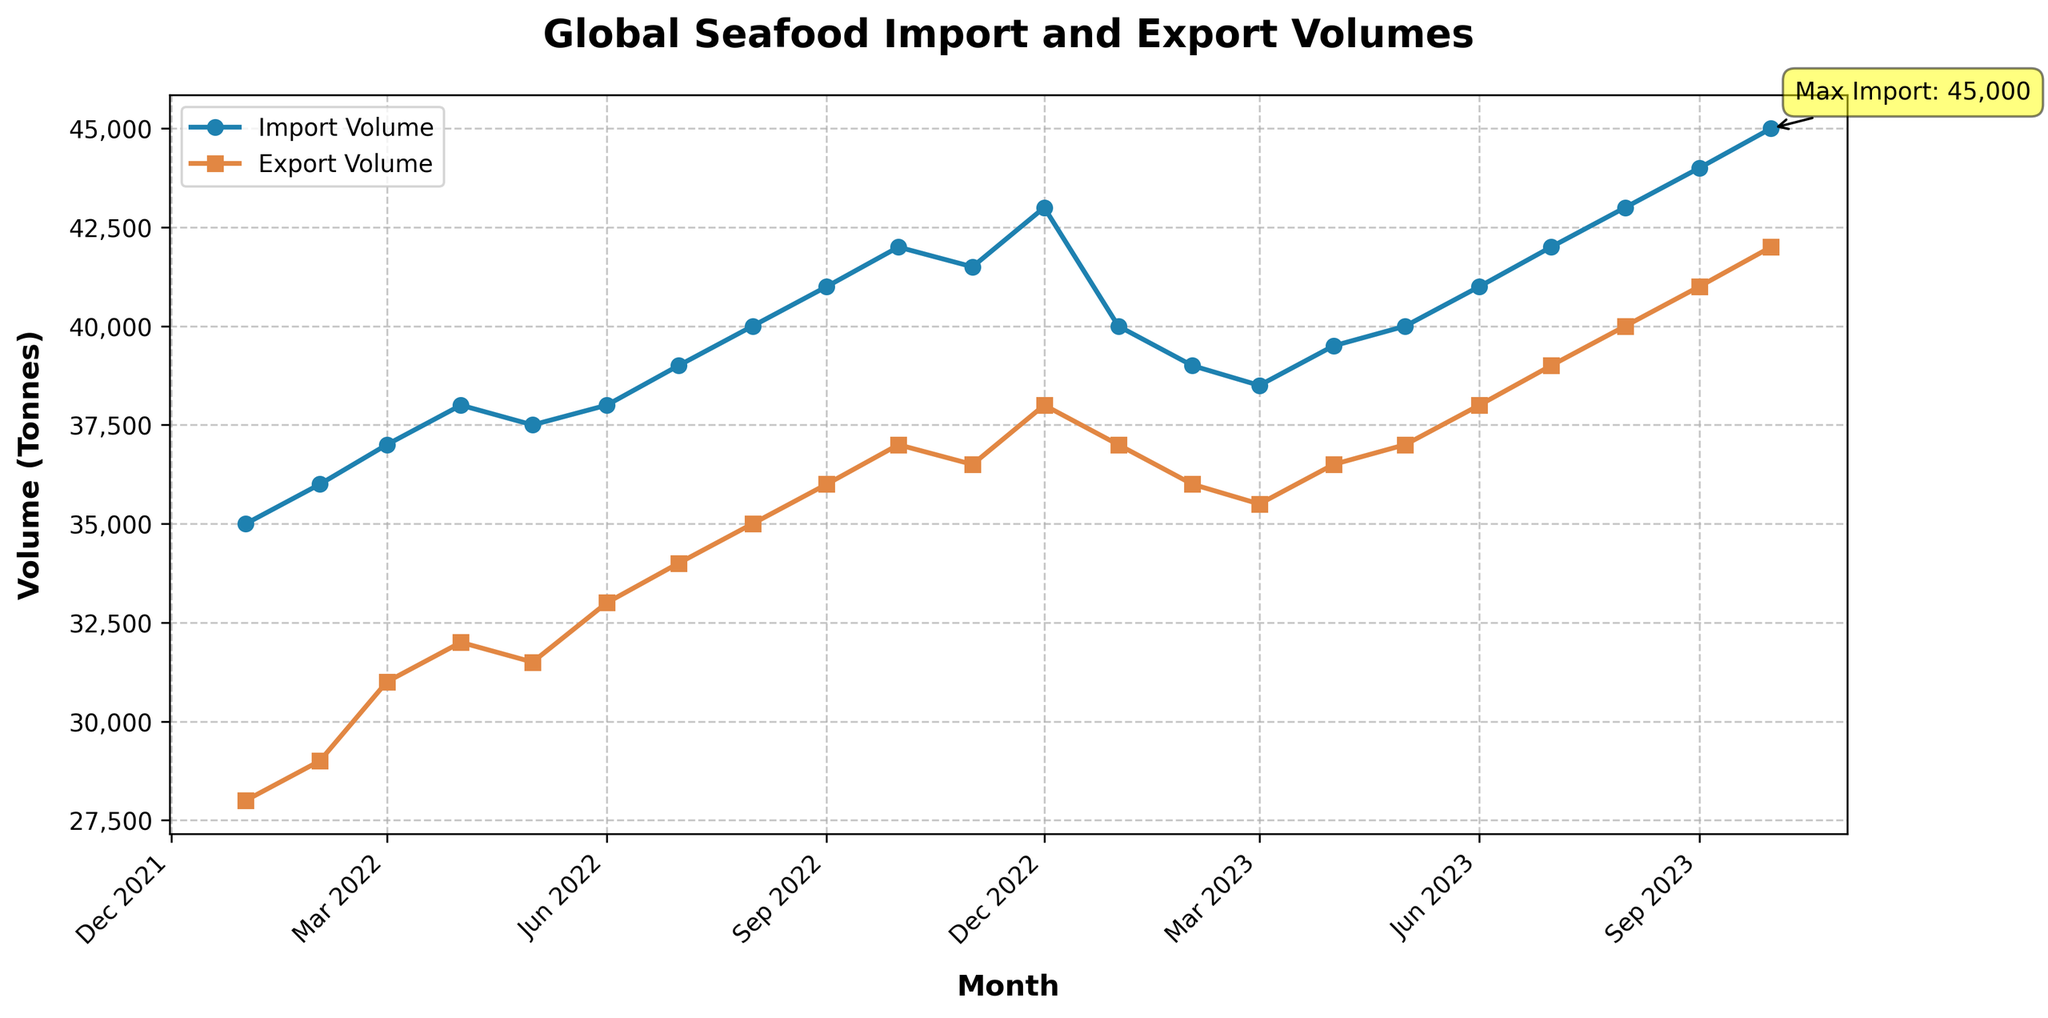What is the title of the plot? The title of the plot is displayed at the top of the figure. It provides a summary of what the chart is about.
Answer: Global Seafood Import and Export Volumes What is the maximum import volume and when did it occur? By examining the 'Import Volume' series, the highest point on the plot represents the maximum import volume. The annotation also highlights it.
Answer: 45,000 tonnes in October 2023 Which month had the lowest export volume and what was its value? By looking at the 'Export Volume' series, the lowest point on the plot represents the lowest export volume. This occurred at the beginning of the series.
Answer: January 2022 with 28,000 tonnes How does the import volume in January 2023 compare to its value in January 2022? By locating January 2022 and January 2023 on the x-axis and comparing their corresponding import values on the y-axis, we can determine the difference or increase.
Answer: Import volume decreased from 35,000 tonnes to 40,000 tonnes Over the entire period, how many months saw a decrease in export volume compared to the previous month? By checking the 'Export Volume' series, each data point can be compared to the previous month to count the months with a decrease. There are three such periods: January 2023, February 2023, and March 2023.
Answer: 3 months What is the general trend for seafood import volumes from January 2022 to October 2023? Observing the 'Import Volume' series, the line generally slopes upwards, indicating an increasing trend over the time period.
Answer: Increasing What's the range of export volume values displayed in the plot? By identifying the highest and lowest export volumes on the plot's y-axis, the range can be calculated as the difference between these two values.
Answer: 14,000 tonnes (from 28,000 to 42,000 tonnes) On average, how much did the import volume change per month throughout the period? Summarize the monthly changes in import volume from January 2022 to October 2023 and divide by the number of months to find the average monthly change.
Answer: Approximately 500 tonnes Which month showed the highest increase in export volume compared to the previous month? By comparing each month's export volume to the previous month, we identify the month with the maximum positive difference.
Answer: January 2023 to February 2023 When did both import and export volumes reach their local maximum values simultaneously? By checking the plot, find out if there's any month where both series peak together. The plot shows October 2023 as having the highest values for both import and export volumes within the given range.
Answer: October 2023 